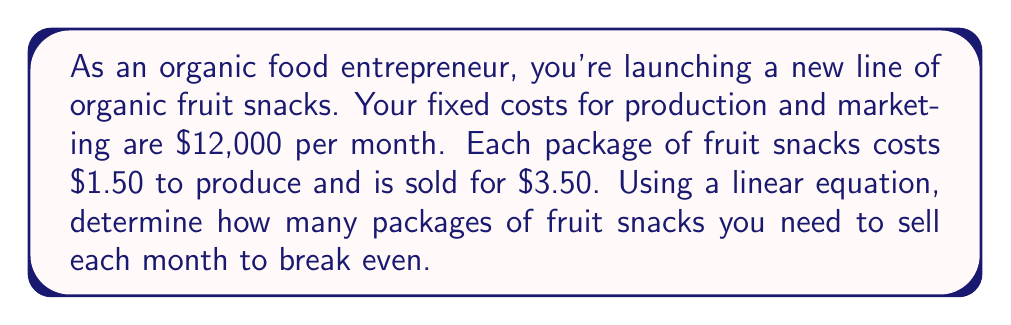Show me your answer to this math problem. To solve this problem, we'll use the break-even formula:

$$ \text{Revenue} = \text{Fixed Costs} + \text{Variable Costs} $$

Let $x$ be the number of packages sold.

Revenue: $3.50x$
Fixed Costs: $12,000$
Variable Costs: $1.50x$

Substituting these into our equation:

$$ 3.50x = 12,000 + 1.50x $$

Now, let's solve for $x$:

$$ 3.50x - 1.50x = 12,000 $$
$$ 2x = 12,000 $$
$$ x = 6,000 $$

To verify:
Revenue: $3.50 \times 6,000 = 21,000$
Total Costs: $12,000 + (1.50 \times 6,000) = 21,000$

Since Revenue = Total Costs, this confirms the break-even point.
Answer: You need to sell 6,000 packages of organic fruit snacks per month to break even. 